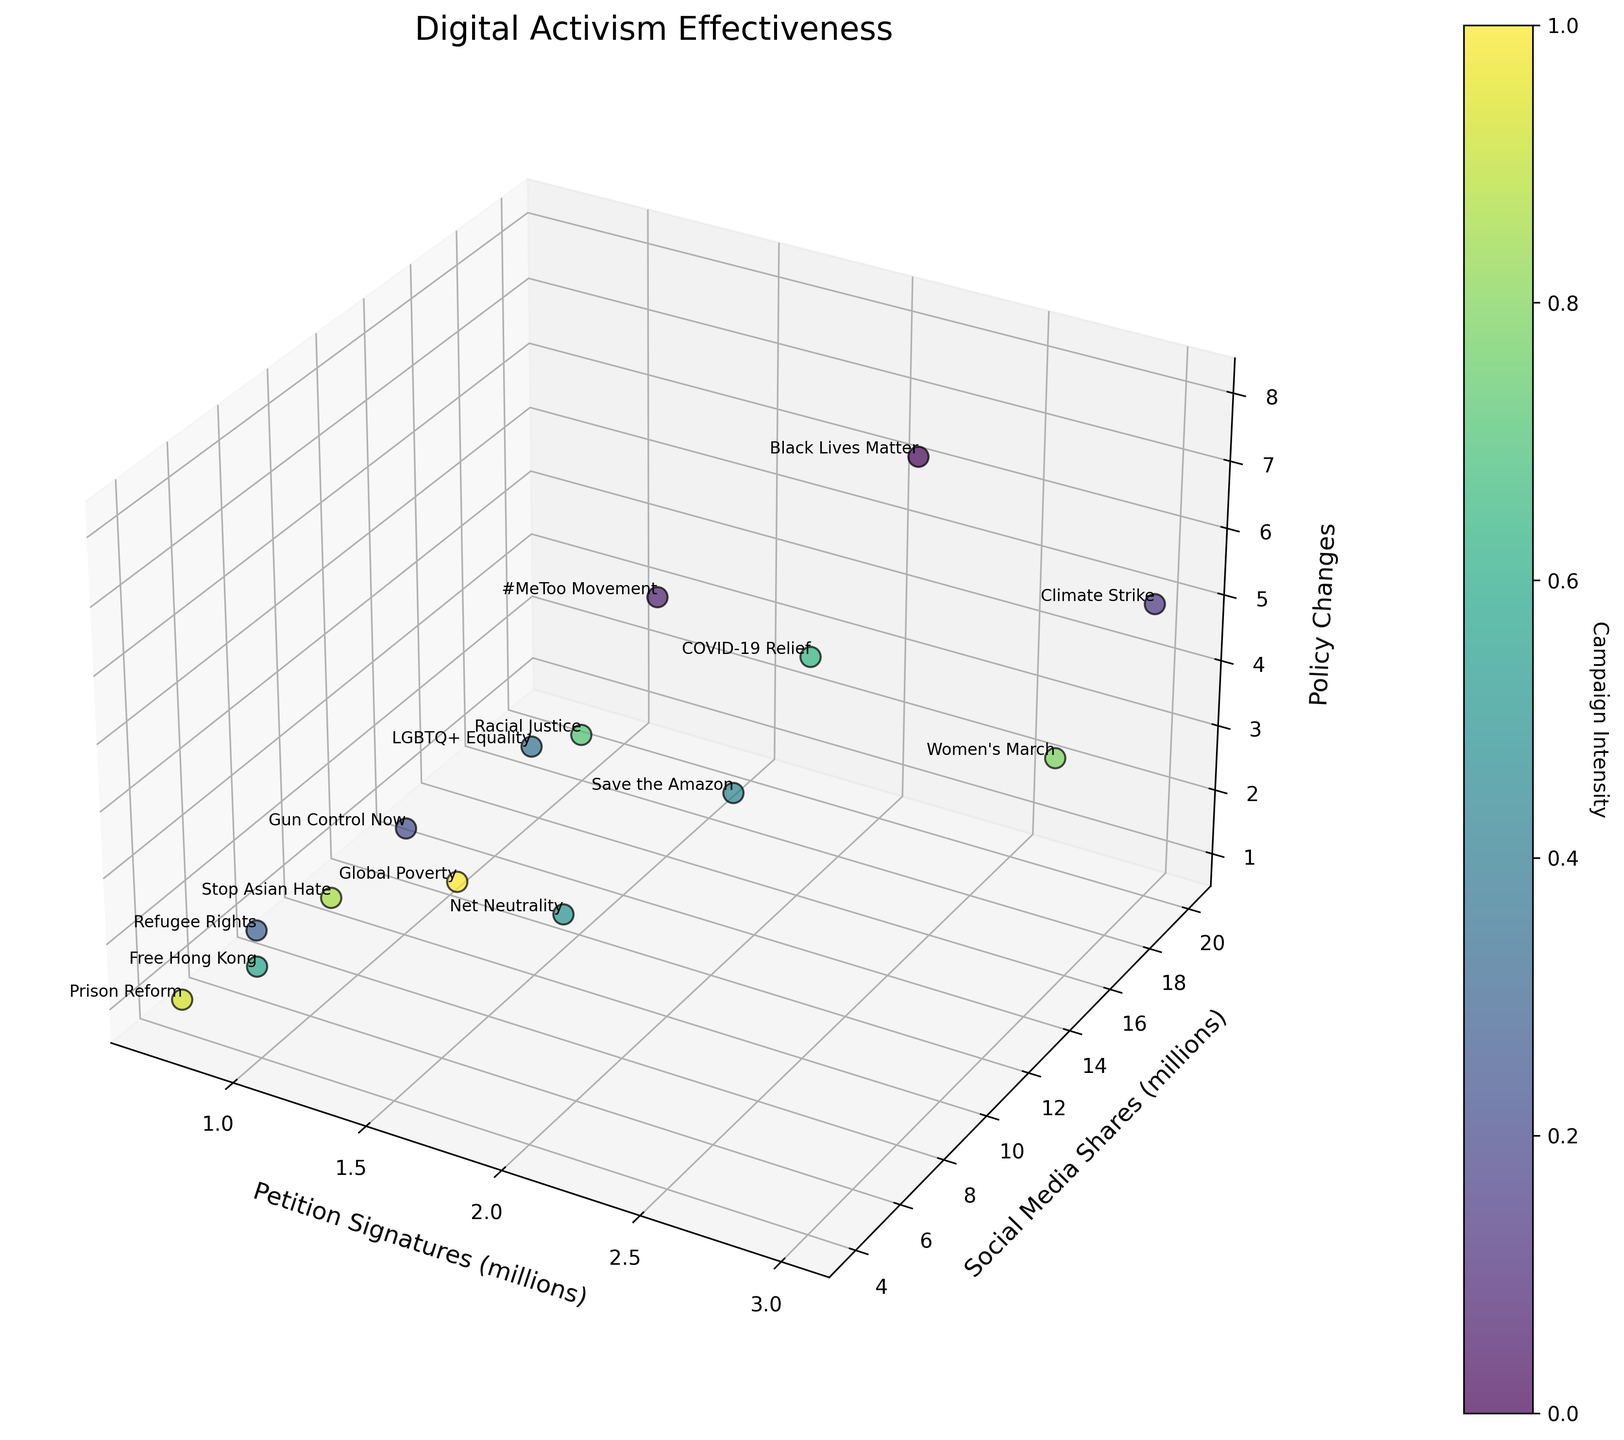How many campaigns are represented in the figure? By observing the figure and counting the number of labeled data points, we can determine the total number of campaigns represented.
Answer: 15 What are the axes labels in the plot? Look at the labeled axes in the plot: the x-axis, y-axis, and z-axis.
Answer: Petition Signatures (millions), Social Media Shares (millions), Policy Changes Which campaign has the highest number of Policy Changes? Identify the campaign associated with the highest z-axis value on the plot. It's labeled next to the point.
Answer: Black Lives Matter What is the difference in Policy Changes between the #MeToo Movement and Gun Control Now campaigns? Locate the z-axis values for both campaigns and subtract the value for Gun Control Now from #MeToo Movement. Values: #MeToo (6) - Gun Control Now (3).
Answer: 3 Which campaign appears to have the closest number of Petition Signatures and Social Media Shares on the plot? Look for data points where the x and y values (Petition Signatures and Social Media Shares) are roughly equal and close together.
Answer: Women's March How many campaigns have at least 4 Policy Changes? Count the data points with a z-axis value greater than or equal to 4.
Answer: 5 Which campaign has the lowest number of Social Media Shares? Identify the campaign associated with the lowest y-axis value.
Answer: Prison Reform What is the total number of Petition Signatures (in millions) for campaigns that resulted in 2 Policy Changes? Sum the x-axis values (in millions) of campaigns that have a z-axis value of 2. Values: Refugee Rights (0.9) + Stop Asian Hate (1.0) + Global Poverty (1.3) + Net Neutrality (1.7).
Answer: 4.9 Which campaigns are positioned at the midpoint value for Social Media Shares on the y-axis? Calculate the midpoint of the y-axis range, then find the campaigns closest to this value. Midpoint = (20 + 4) / 2 = 12. Campaigns closest to 12 million shares are #MeToo Movement, LGBTQ+ Equality.
Answer: #MeToo Movement, LGBTQ+ Equality Do any campaigns have the same number of Petition Signatures and Policy Changes? Compare x (Petition Signatures in millions) and z (Policy Changes) values across campaigns to check for equality.
Answer: No 